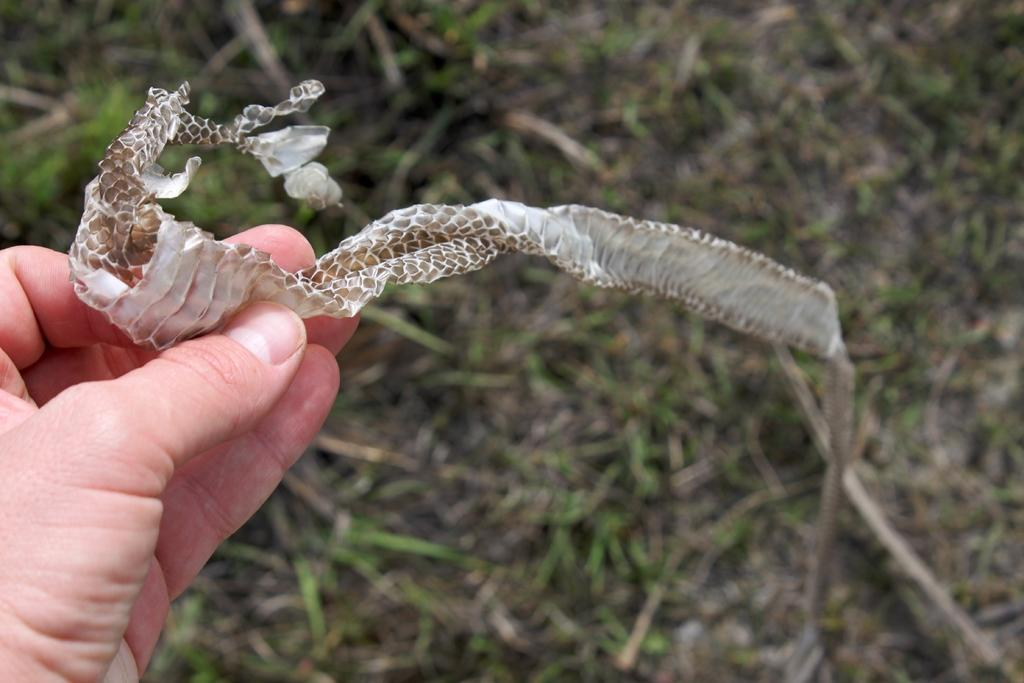What is the person holding in the image? There is a person's hand holding snake skin in the image. Can you describe the background of the image? The background of the image is blurred. What type of magic is being performed with the cows in the image? There are no cows present in the image, and no magic is being performed. 